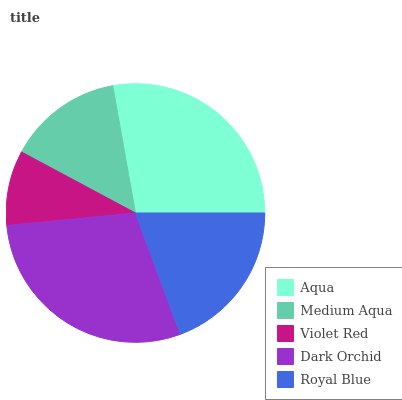Is Violet Red the minimum?
Answer yes or no. Yes. Is Dark Orchid the maximum?
Answer yes or no. Yes. Is Medium Aqua the minimum?
Answer yes or no. No. Is Medium Aqua the maximum?
Answer yes or no. No. Is Aqua greater than Medium Aqua?
Answer yes or no. Yes. Is Medium Aqua less than Aqua?
Answer yes or no. Yes. Is Medium Aqua greater than Aqua?
Answer yes or no. No. Is Aqua less than Medium Aqua?
Answer yes or no. No. Is Royal Blue the high median?
Answer yes or no. Yes. Is Royal Blue the low median?
Answer yes or no. Yes. Is Medium Aqua the high median?
Answer yes or no. No. Is Medium Aqua the low median?
Answer yes or no. No. 